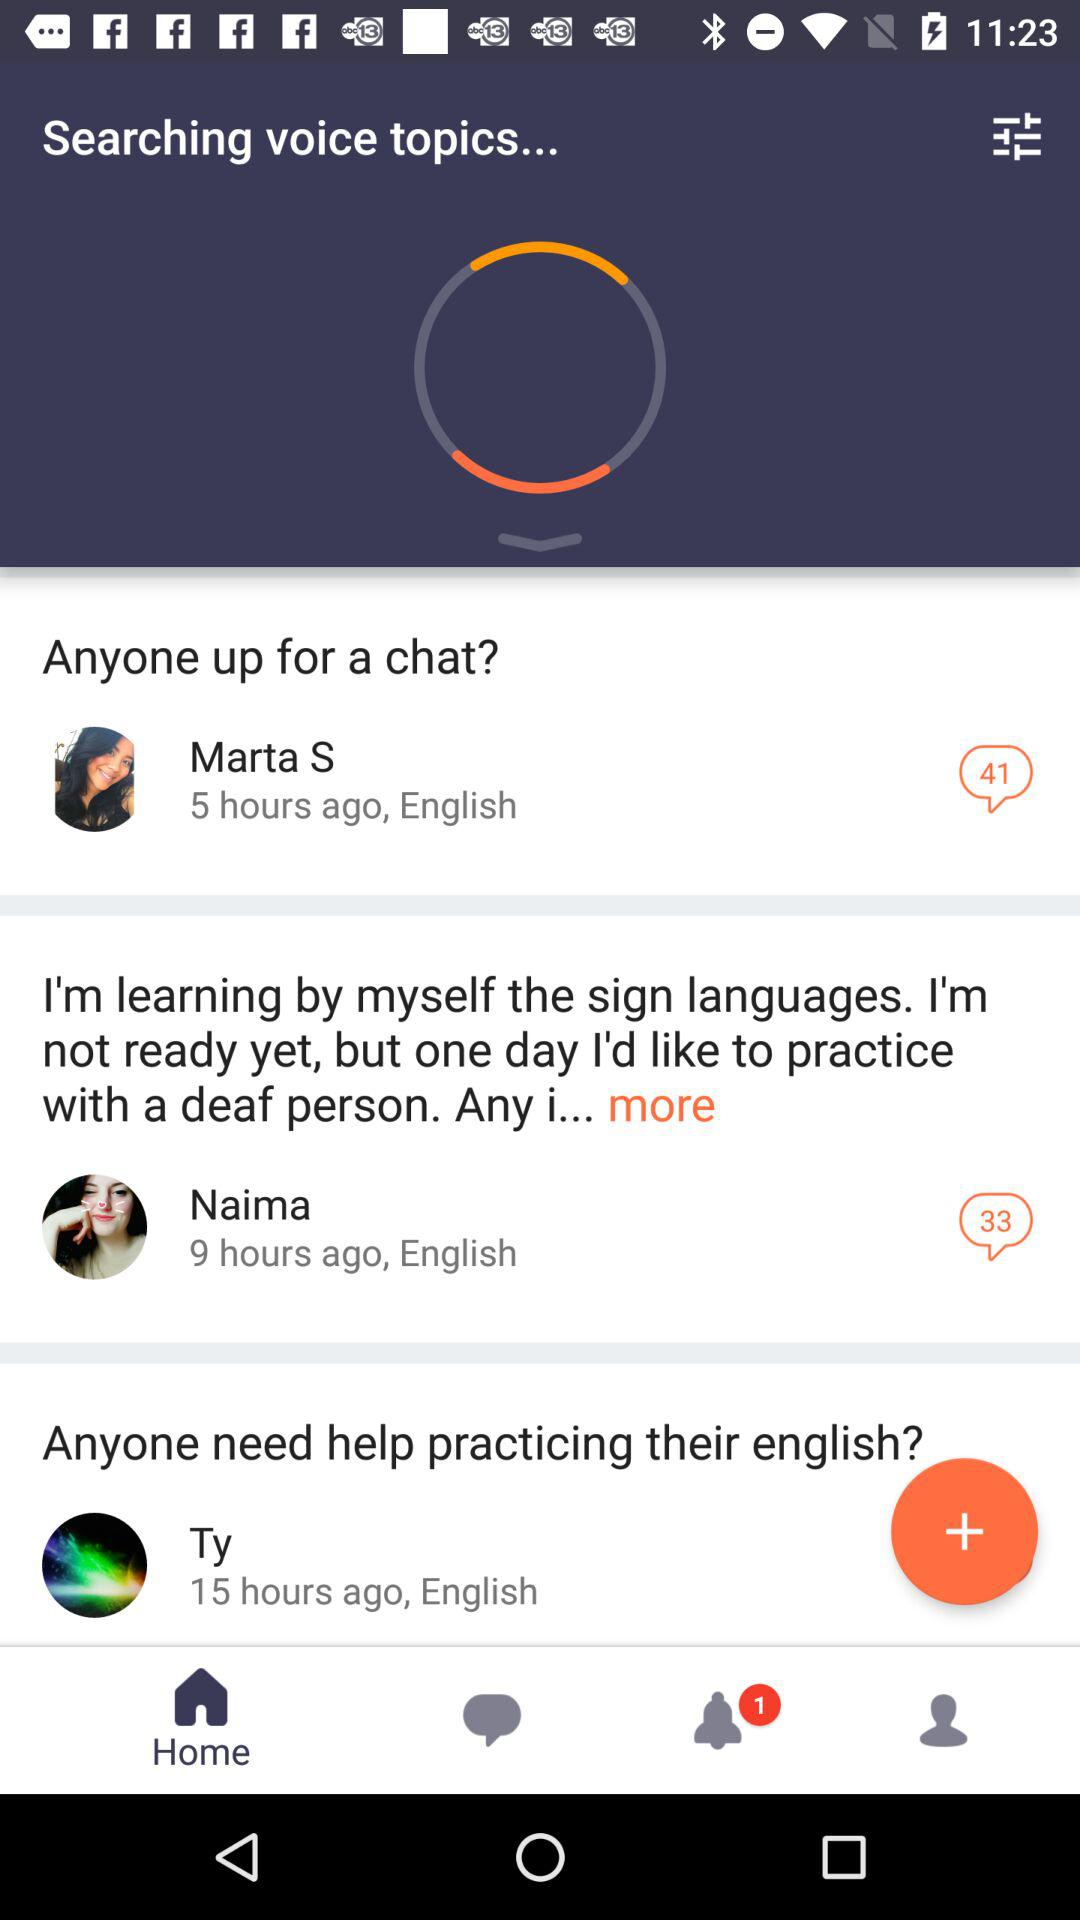When did Marta post a message? Marta posted a message 5 hours ago. 